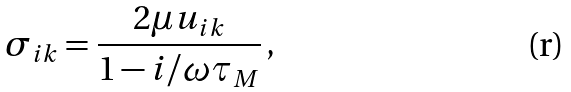Convert formula to latex. <formula><loc_0><loc_0><loc_500><loc_500>\sigma _ { i k } = \frac { 2 \mu u _ { i k } } { 1 - i / \omega \tau _ { M } } \, ,</formula> 